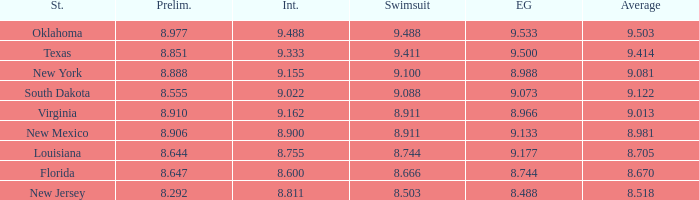 what's the preliminaries where evening gown is 8.988 8.888. 